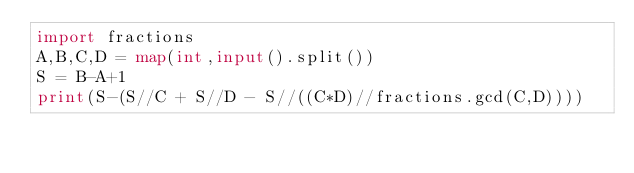Convert code to text. <code><loc_0><loc_0><loc_500><loc_500><_Python_>import fractions
A,B,C,D = map(int,input().split())
S = B-A+1
print(S-(S//C + S//D - S//((C*D)//fractions.gcd(C,D))))</code> 